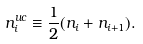<formula> <loc_0><loc_0><loc_500><loc_500>n _ { i } ^ { u c } \equiv \frac { 1 } { 2 } ( n _ { i } + n _ { i + 1 } ) .</formula> 